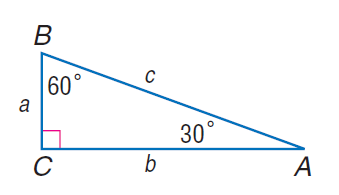Answer the mathemtical geometry problem and directly provide the correct option letter.
Question: If b = 18, find a.
Choices: A: 9 B: 6 \sqrt { 3 } C: 9 \sqrt { 3 } D: 12 \sqrt { 3 } B 